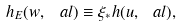<formula> <loc_0><loc_0><loc_500><loc_500>h _ { E } ( w , \ a l ) \equiv \xi _ { * } h ( u , \ a l ) ,</formula> 